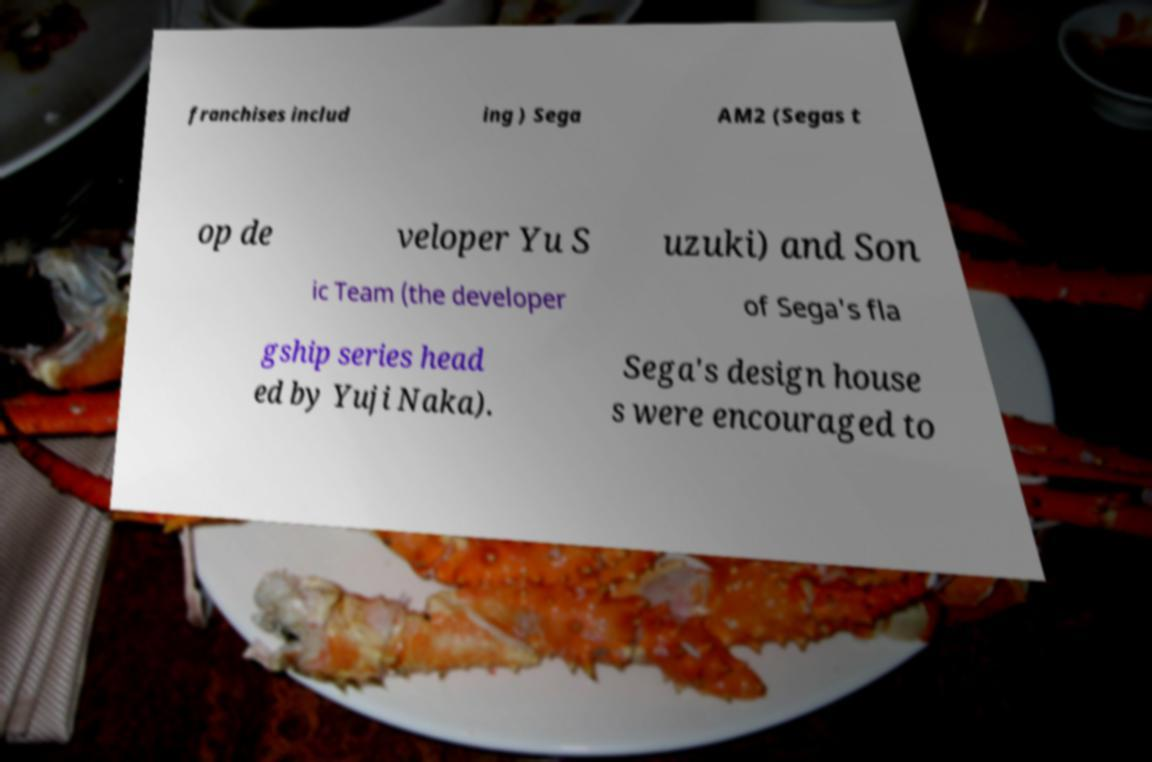Can you accurately transcribe the text from the provided image for me? franchises includ ing ) Sega AM2 (Segas t op de veloper Yu S uzuki) and Son ic Team (the developer of Sega's fla gship series head ed by Yuji Naka). Sega's design house s were encouraged to 